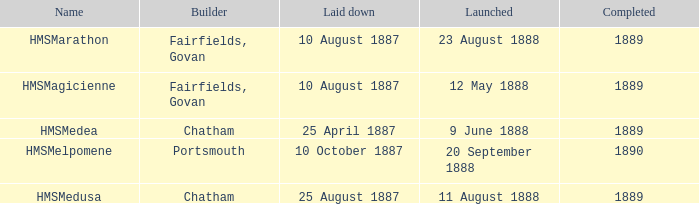When did chatham complete the Hmsmedusa? 1889.0. 